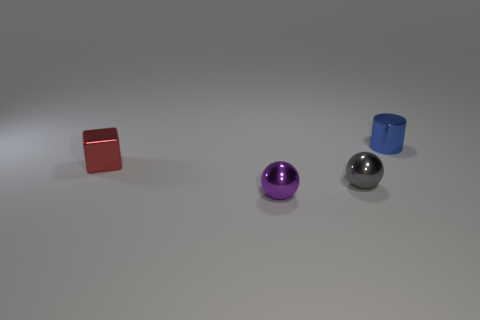How many other things are the same color as the small block?
Provide a short and direct response. 0. What number of yellow objects are either tiny metal blocks or big spheres?
Offer a terse response. 0. Is there a tiny cube on the right side of the small metallic ball that is on the right side of the small sphere in front of the small gray ball?
Keep it short and to the point. No. Is there anything else that has the same size as the gray object?
Offer a terse response. Yes. Is the color of the block the same as the tiny cylinder?
Provide a succinct answer. No. What color is the metallic ball that is behind the tiny shiny ball that is to the left of the small gray thing?
Your answer should be very brief. Gray. How many small objects are metallic things or red shiny things?
Ensure brevity in your answer.  4. What is the color of the shiny thing that is in front of the cube and behind the purple ball?
Ensure brevity in your answer.  Gray. Is the material of the purple object the same as the tiny red cube?
Your answer should be compact. Yes. There is a blue object; what shape is it?
Your answer should be compact. Cylinder. 